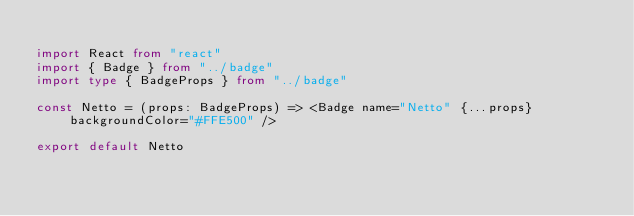Convert code to text. <code><loc_0><loc_0><loc_500><loc_500><_TypeScript_>
import React from "react"
import { Badge } from "../badge"
import type { BadgeProps } from "../badge"

const Netto = (props: BadgeProps) => <Badge name="Netto" {...props} backgroundColor="#FFE500" />

export default Netto
</code> 